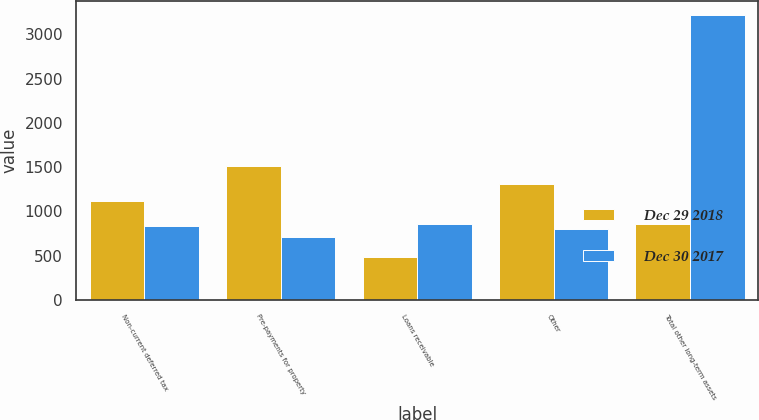<chart> <loc_0><loc_0><loc_500><loc_500><stacked_bar_chart><ecel><fcel>Non-current deferred tax<fcel>Pre-payments for property<fcel>Loans receivable<fcel>Other<fcel>Total other long-term assets<nl><fcel>Dec 29 2018<fcel>1122<fcel>1507<fcel>479<fcel>1313<fcel>860<nl><fcel>Dec 30 2017<fcel>840<fcel>714<fcel>860<fcel>801<fcel>3215<nl></chart> 